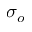Convert formula to latex. <formula><loc_0><loc_0><loc_500><loc_500>\sigma _ { o }</formula> 